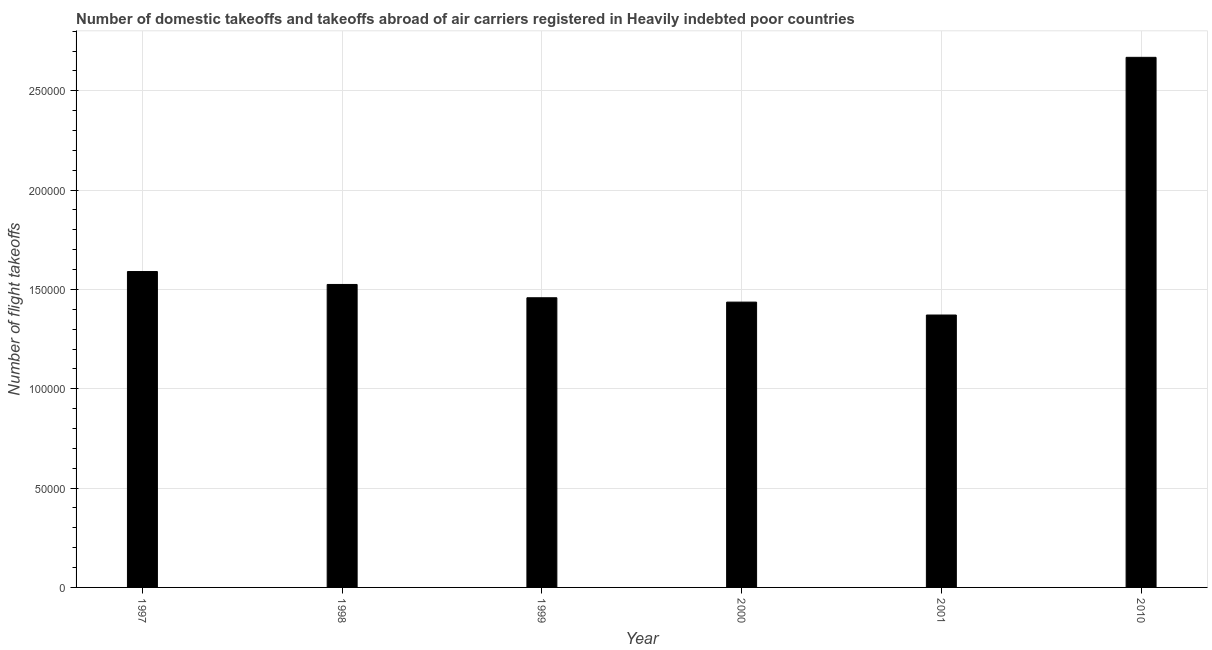Does the graph contain grids?
Give a very brief answer. Yes. What is the title of the graph?
Your answer should be very brief. Number of domestic takeoffs and takeoffs abroad of air carriers registered in Heavily indebted poor countries. What is the label or title of the X-axis?
Give a very brief answer. Year. What is the label or title of the Y-axis?
Make the answer very short. Number of flight takeoffs. What is the number of flight takeoffs in 1997?
Provide a succinct answer. 1.59e+05. Across all years, what is the maximum number of flight takeoffs?
Your answer should be compact. 2.67e+05. Across all years, what is the minimum number of flight takeoffs?
Give a very brief answer. 1.37e+05. In which year was the number of flight takeoffs maximum?
Your response must be concise. 2010. What is the sum of the number of flight takeoffs?
Make the answer very short. 1.00e+06. What is the difference between the number of flight takeoffs in 2000 and 2001?
Your answer should be compact. 6498. What is the average number of flight takeoffs per year?
Your answer should be very brief. 1.67e+05. What is the median number of flight takeoffs?
Make the answer very short. 1.49e+05. Do a majority of the years between 2000 and 2010 (inclusive) have number of flight takeoffs greater than 40000 ?
Your answer should be compact. Yes. What is the ratio of the number of flight takeoffs in 1997 to that in 1998?
Ensure brevity in your answer.  1.04. What is the difference between the highest and the second highest number of flight takeoffs?
Ensure brevity in your answer.  1.08e+05. What is the difference between the highest and the lowest number of flight takeoffs?
Provide a short and direct response. 1.30e+05. How many bars are there?
Ensure brevity in your answer.  6. Are all the bars in the graph horizontal?
Keep it short and to the point. No. How many years are there in the graph?
Ensure brevity in your answer.  6. What is the difference between two consecutive major ticks on the Y-axis?
Your answer should be compact. 5.00e+04. What is the Number of flight takeoffs of 1997?
Offer a very short reply. 1.59e+05. What is the Number of flight takeoffs in 1998?
Offer a terse response. 1.52e+05. What is the Number of flight takeoffs in 1999?
Provide a short and direct response. 1.46e+05. What is the Number of flight takeoffs in 2000?
Your response must be concise. 1.44e+05. What is the Number of flight takeoffs of 2001?
Provide a short and direct response. 1.37e+05. What is the Number of flight takeoffs in 2010?
Your answer should be very brief. 2.67e+05. What is the difference between the Number of flight takeoffs in 1997 and 1998?
Your answer should be very brief. 6500. What is the difference between the Number of flight takeoffs in 1997 and 1999?
Provide a short and direct response. 1.32e+04. What is the difference between the Number of flight takeoffs in 1997 and 2000?
Make the answer very short. 1.54e+04. What is the difference between the Number of flight takeoffs in 1997 and 2001?
Your answer should be compact. 2.19e+04. What is the difference between the Number of flight takeoffs in 1997 and 2010?
Make the answer very short. -1.08e+05. What is the difference between the Number of flight takeoffs in 1998 and 1999?
Offer a very short reply. 6700. What is the difference between the Number of flight takeoffs in 1998 and 2000?
Offer a terse response. 8888. What is the difference between the Number of flight takeoffs in 1998 and 2001?
Ensure brevity in your answer.  1.54e+04. What is the difference between the Number of flight takeoffs in 1998 and 2010?
Your response must be concise. -1.14e+05. What is the difference between the Number of flight takeoffs in 1999 and 2000?
Offer a very short reply. 2188. What is the difference between the Number of flight takeoffs in 1999 and 2001?
Keep it short and to the point. 8686. What is the difference between the Number of flight takeoffs in 1999 and 2010?
Offer a terse response. -1.21e+05. What is the difference between the Number of flight takeoffs in 2000 and 2001?
Your response must be concise. 6498. What is the difference between the Number of flight takeoffs in 2000 and 2010?
Offer a very short reply. -1.23e+05. What is the difference between the Number of flight takeoffs in 2001 and 2010?
Your answer should be very brief. -1.30e+05. What is the ratio of the Number of flight takeoffs in 1997 to that in 1998?
Make the answer very short. 1.04. What is the ratio of the Number of flight takeoffs in 1997 to that in 1999?
Offer a terse response. 1.09. What is the ratio of the Number of flight takeoffs in 1997 to that in 2000?
Provide a succinct answer. 1.11. What is the ratio of the Number of flight takeoffs in 1997 to that in 2001?
Ensure brevity in your answer.  1.16. What is the ratio of the Number of flight takeoffs in 1997 to that in 2010?
Your response must be concise. 0.6. What is the ratio of the Number of flight takeoffs in 1998 to that in 1999?
Give a very brief answer. 1.05. What is the ratio of the Number of flight takeoffs in 1998 to that in 2000?
Your response must be concise. 1.06. What is the ratio of the Number of flight takeoffs in 1998 to that in 2001?
Ensure brevity in your answer.  1.11. What is the ratio of the Number of flight takeoffs in 1998 to that in 2010?
Give a very brief answer. 0.57. What is the ratio of the Number of flight takeoffs in 1999 to that in 2001?
Your answer should be compact. 1.06. What is the ratio of the Number of flight takeoffs in 1999 to that in 2010?
Ensure brevity in your answer.  0.55. What is the ratio of the Number of flight takeoffs in 2000 to that in 2001?
Your answer should be compact. 1.05. What is the ratio of the Number of flight takeoffs in 2000 to that in 2010?
Your answer should be very brief. 0.54. What is the ratio of the Number of flight takeoffs in 2001 to that in 2010?
Your response must be concise. 0.51. 